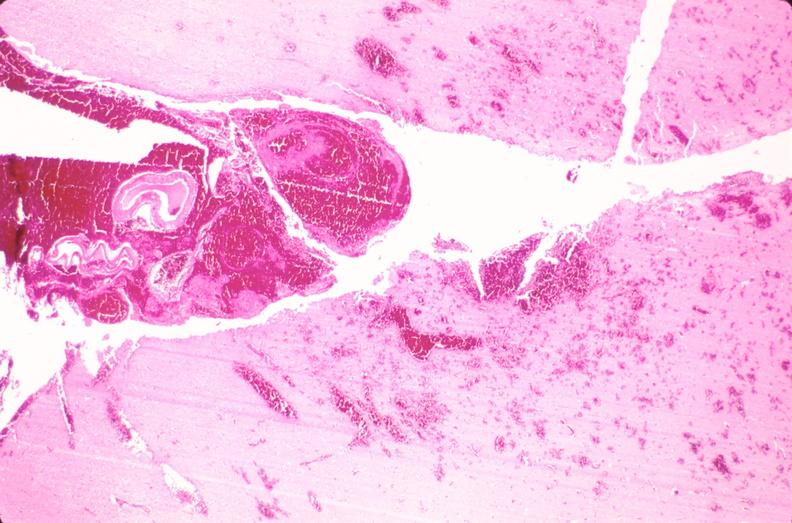where is this?
Answer the question using a single word or phrase. Nervous 